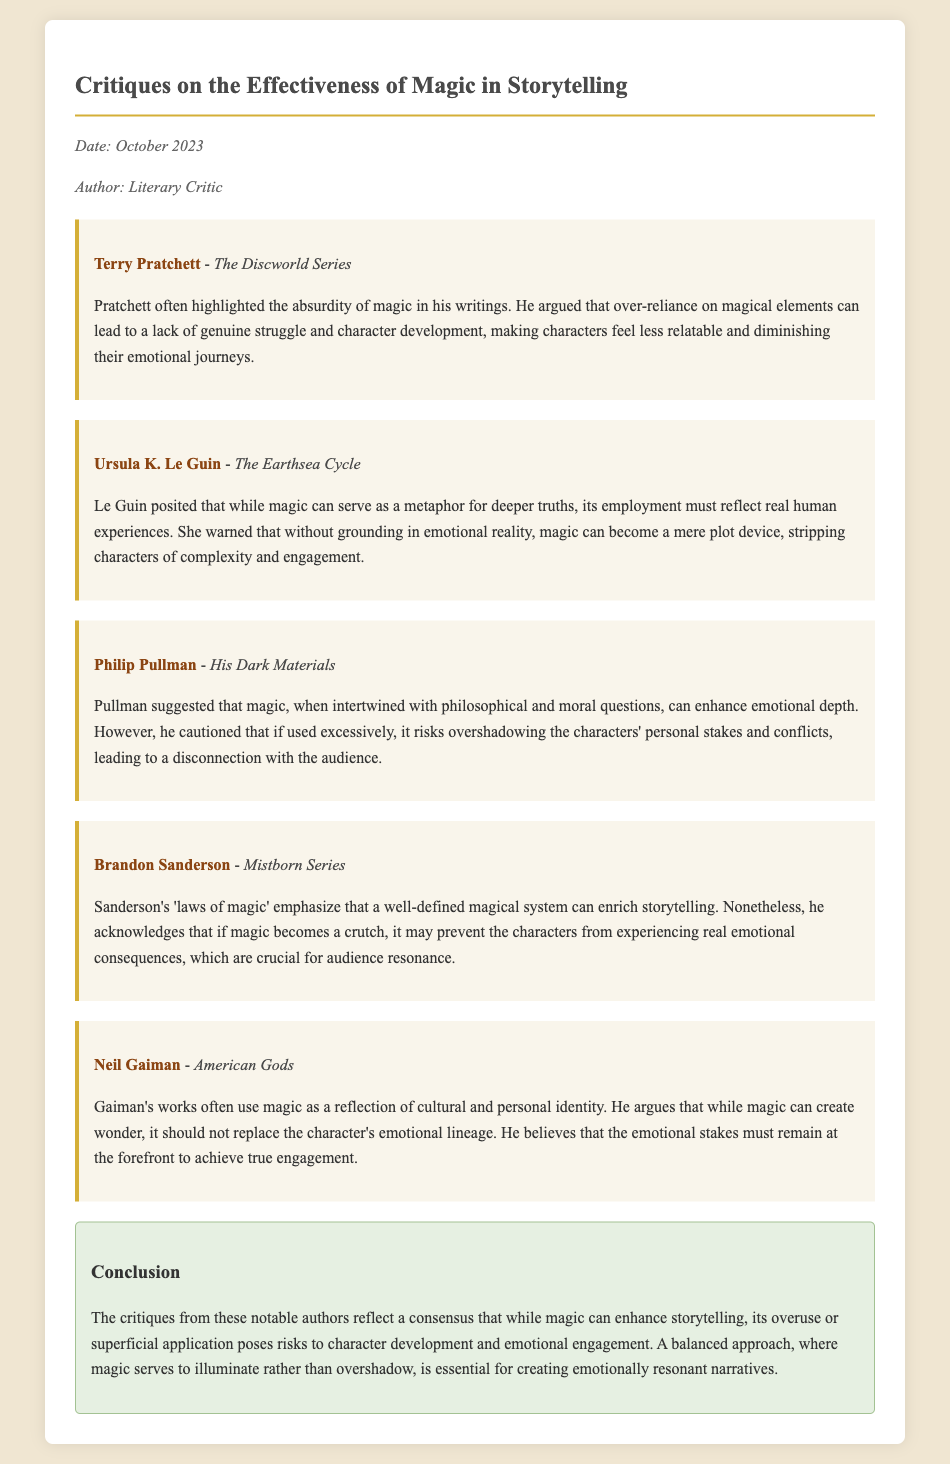What is the title of the memo? The title of the memo is presented prominently at the top, summarizing its content on critiques.
Answer: Critiques on the Effectiveness of Magic in Storytelling Who is the author of the memo? The author is indicated in the metadata section of the document, specifying the individual who wrote the memo.
Answer: Literary Critic Which author discussed the absurdity of magic? The document provides insights from various authors, and one specifically addresses the absurdity of magic in their work.
Answer: Terry Pratchett In which work did Ursula K. Le Guin discuss magic? The memo cites specific works associated with each author that provide context for their critiques.
Answer: The Earthsea Cycle What is the key warning given by Le Guin regarding magic? The document outlines Le Guin's views on magic and its potential pitfalls in storytelling, highlighting a particular concern.
Answer: Stripping characters of complexity and engagement How does Philip Pullman view the relationship between magic and emotional depth? Pullman's perspective on magic and its interrelation with emotional depth is articulated in the memo, offering a nuanced view.
Answer: Enhance emotional depth What does Neil Gaiman suggest magic should not replace? Gaiman emphasizes that certain elements are crucial in narratives, and magic should not overshadow them, which is noted in the critique.
Answer: The character's emotional lineage What are Brandon Sanderson's 'laws of magic'? The document mentions Sanderson's framework that contributes to the understanding of magic in storytelling.
Answer: Well-defined magical system What is the consensus among the authors regarding magic in storytelling? The conclusion section summarizes the shared insights from the authors about the effect of magic, highlighting a common perspective.
Answer: Overuse can diminish emotional engagement 